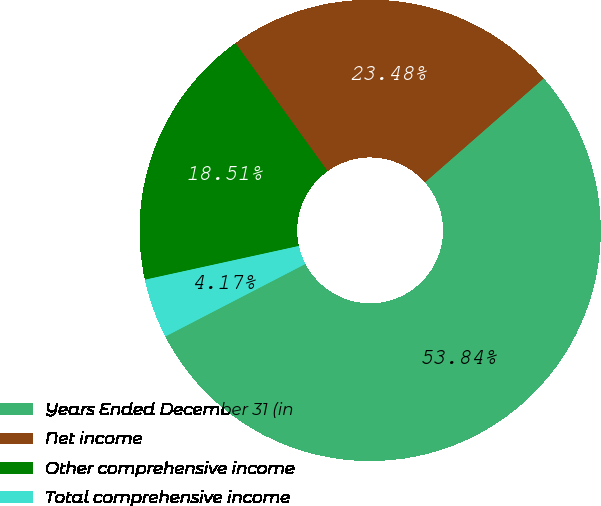Convert chart to OTSL. <chart><loc_0><loc_0><loc_500><loc_500><pie_chart><fcel>Years Ended December 31 (in<fcel>Net income<fcel>Other comprehensive income<fcel>Total comprehensive income<nl><fcel>53.85%<fcel>23.48%<fcel>18.51%<fcel>4.17%<nl></chart> 